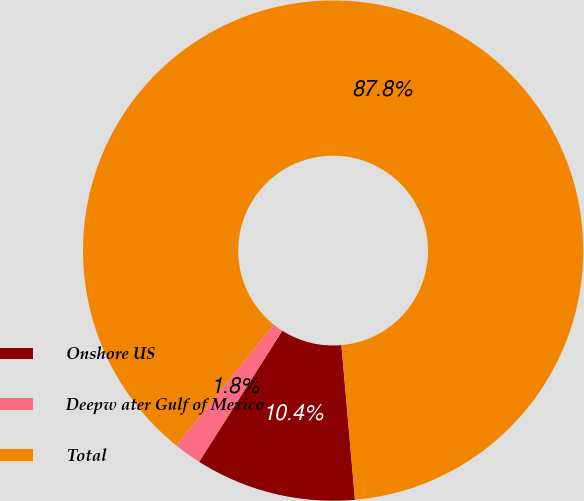Convert chart. <chart><loc_0><loc_0><loc_500><loc_500><pie_chart><fcel>Onshore US<fcel>Deepw ater Gulf of Mexico<fcel>Total<nl><fcel>10.39%<fcel>1.78%<fcel>87.83%<nl></chart> 